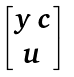<formula> <loc_0><loc_0><loc_500><loc_500>\begin{bmatrix} y \, c \\ u \end{bmatrix}</formula> 